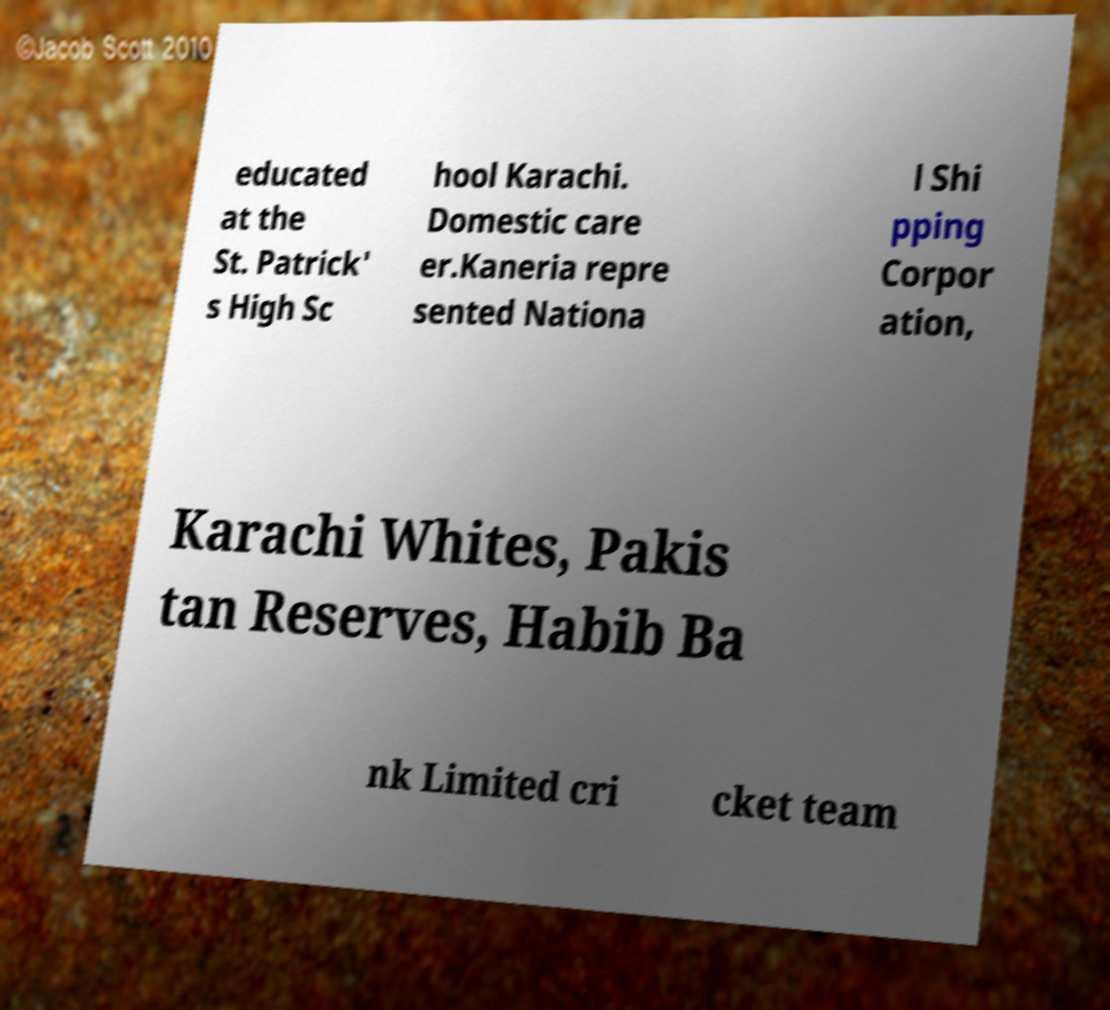There's text embedded in this image that I need extracted. Can you transcribe it verbatim? educated at the St. Patrick' s High Sc hool Karachi. Domestic care er.Kaneria repre sented Nationa l Shi pping Corpor ation, Karachi Whites, Pakis tan Reserves, Habib Ba nk Limited cri cket team 